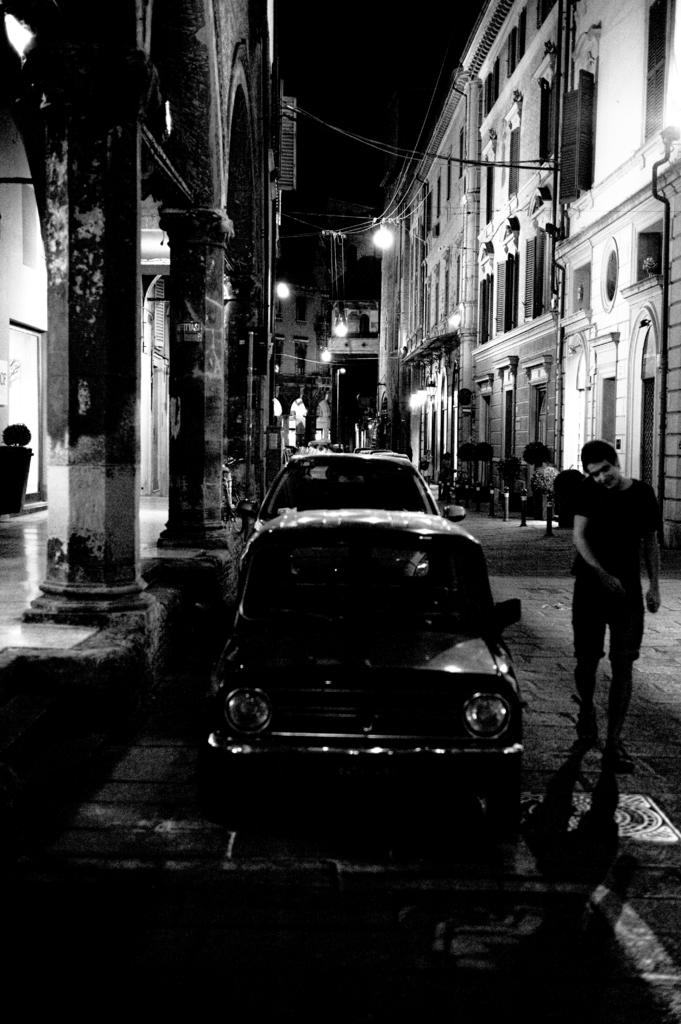What type of structures can be seen in the image? There are buildings in the image. What else is visible in the image besides the buildings? There are lights, cars, people, and the sky visible in the image. Can you describe the lighting conditions in the image? The image appears to be slightly dark. What type of thunder can be heard in the image? There is no thunder present in the image, as it is a visual representation and does not include sound. 